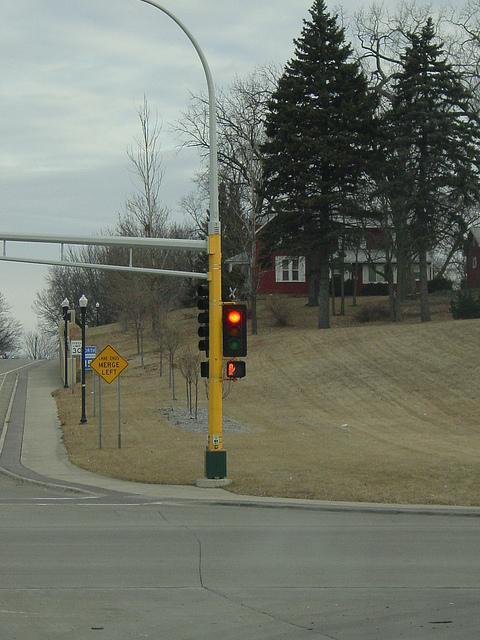Where is the house located?
Indicate the correct response and explain using: 'Answer: answer
Rationale: rationale.'
Options: Beach, lake, hill, valley. Answer: hill.
Rationale: It is at a higher elevation than the streetlight 